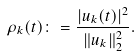<formula> <loc_0><loc_0><loc_500><loc_500>\rho _ { k } ( t ) \colon = \frac { | u _ { k } ( t ) | ^ { 2 } } { \| u _ { k } \| ^ { 2 } _ { 2 } } .</formula> 